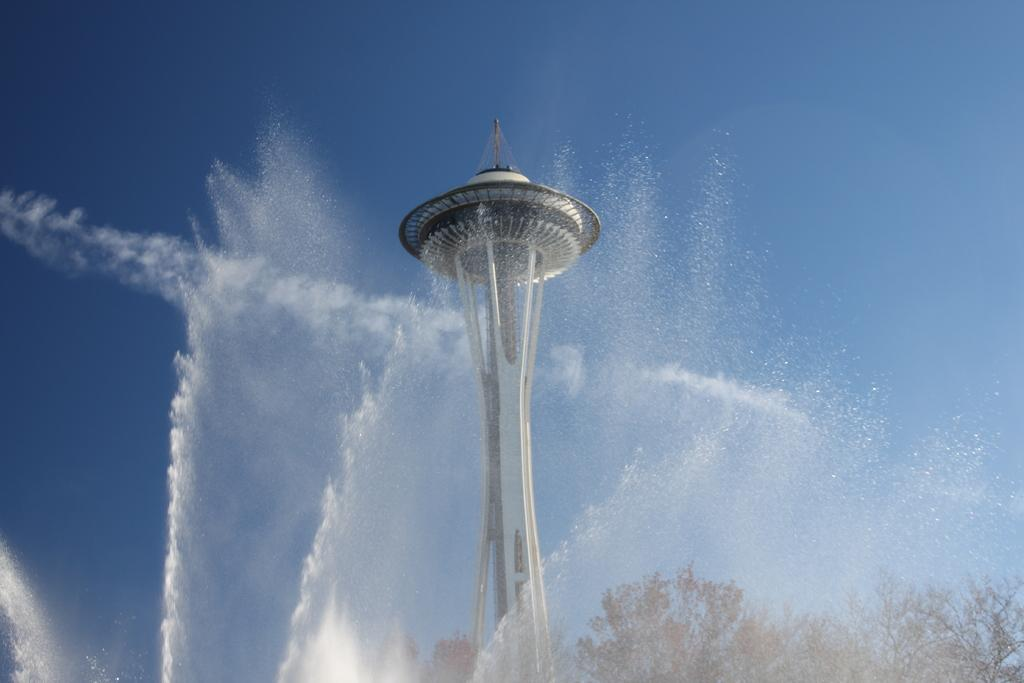What is the main structure in the center of the image? There is a tower in the center of the image. What can be found at the bottom of the image? There is a fountain at the bottom of the image. What type of vegetation is visible in the background of the image? There are trees in the background of the image. What else can be seen in the background of the image? The sky is visible in the background of the image. What type of scale is used by the judge in the image? There is no judge or scale present in the image. How does the sleet affect the tower in the image? There is no sleet present in the image, so it cannot affect the tower. 